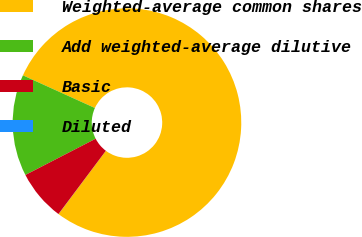<chart> <loc_0><loc_0><loc_500><loc_500><pie_chart><fcel>Weighted-average common shares<fcel>Add weighted-average dilutive<fcel>Basic<fcel>Diluted<nl><fcel>78.44%<fcel>14.36%<fcel>7.19%<fcel>0.01%<nl></chart> 